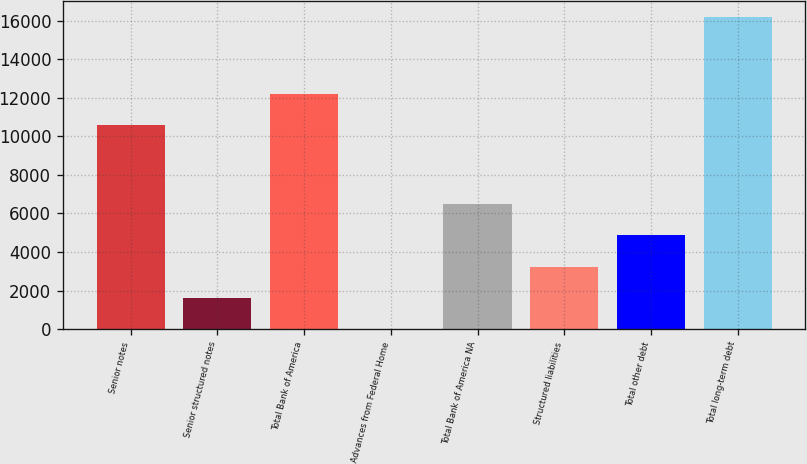<chart> <loc_0><loc_0><loc_500><loc_500><bar_chart><fcel>Senior notes<fcel>Senior structured notes<fcel>Total Bank of America<fcel>Advances from Federal Home<fcel>Total Bank of America NA<fcel>Structured liabilities<fcel>Total other debt<fcel>Total long-term debt<nl><fcel>10580<fcel>1629.8<fcel>12198.8<fcel>11<fcel>6486.2<fcel>3248.6<fcel>4867.4<fcel>16199<nl></chart> 